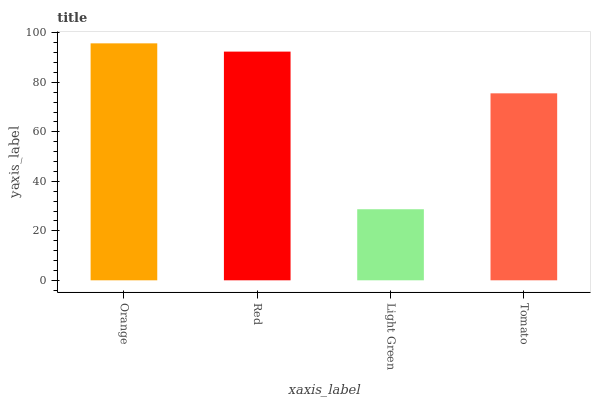Is Light Green the minimum?
Answer yes or no. Yes. Is Orange the maximum?
Answer yes or no. Yes. Is Red the minimum?
Answer yes or no. No. Is Red the maximum?
Answer yes or no. No. Is Orange greater than Red?
Answer yes or no. Yes. Is Red less than Orange?
Answer yes or no. Yes. Is Red greater than Orange?
Answer yes or no. No. Is Orange less than Red?
Answer yes or no. No. Is Red the high median?
Answer yes or no. Yes. Is Tomato the low median?
Answer yes or no. Yes. Is Tomato the high median?
Answer yes or no. No. Is Light Green the low median?
Answer yes or no. No. 